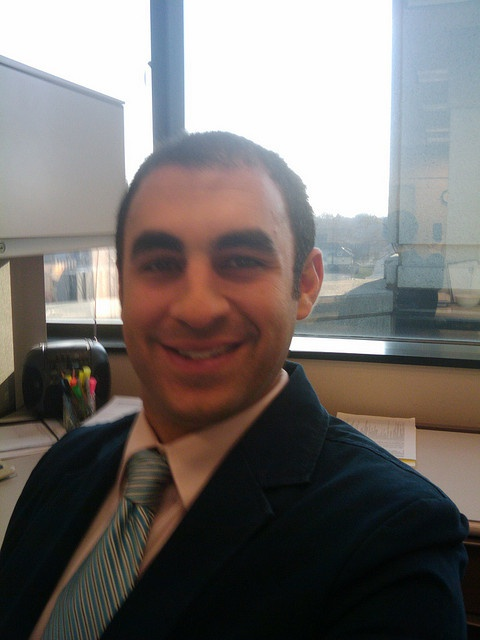Describe the objects in this image and their specific colors. I can see people in white, black, maroon, brown, and gray tones and tie in white, black, and gray tones in this image. 